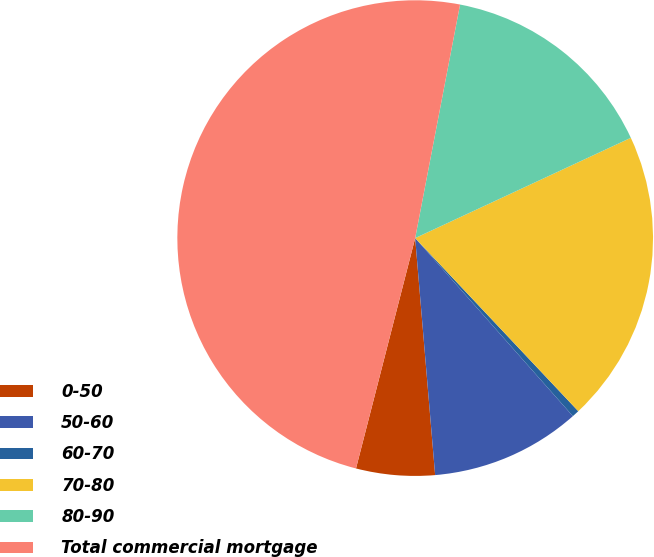Convert chart. <chart><loc_0><loc_0><loc_500><loc_500><pie_chart><fcel>0-50<fcel>50-60<fcel>60-70<fcel>70-80<fcel>80-90<fcel>Total commercial mortgage<nl><fcel>5.34%<fcel>10.2%<fcel>0.49%<fcel>19.9%<fcel>15.05%<fcel>49.02%<nl></chart> 